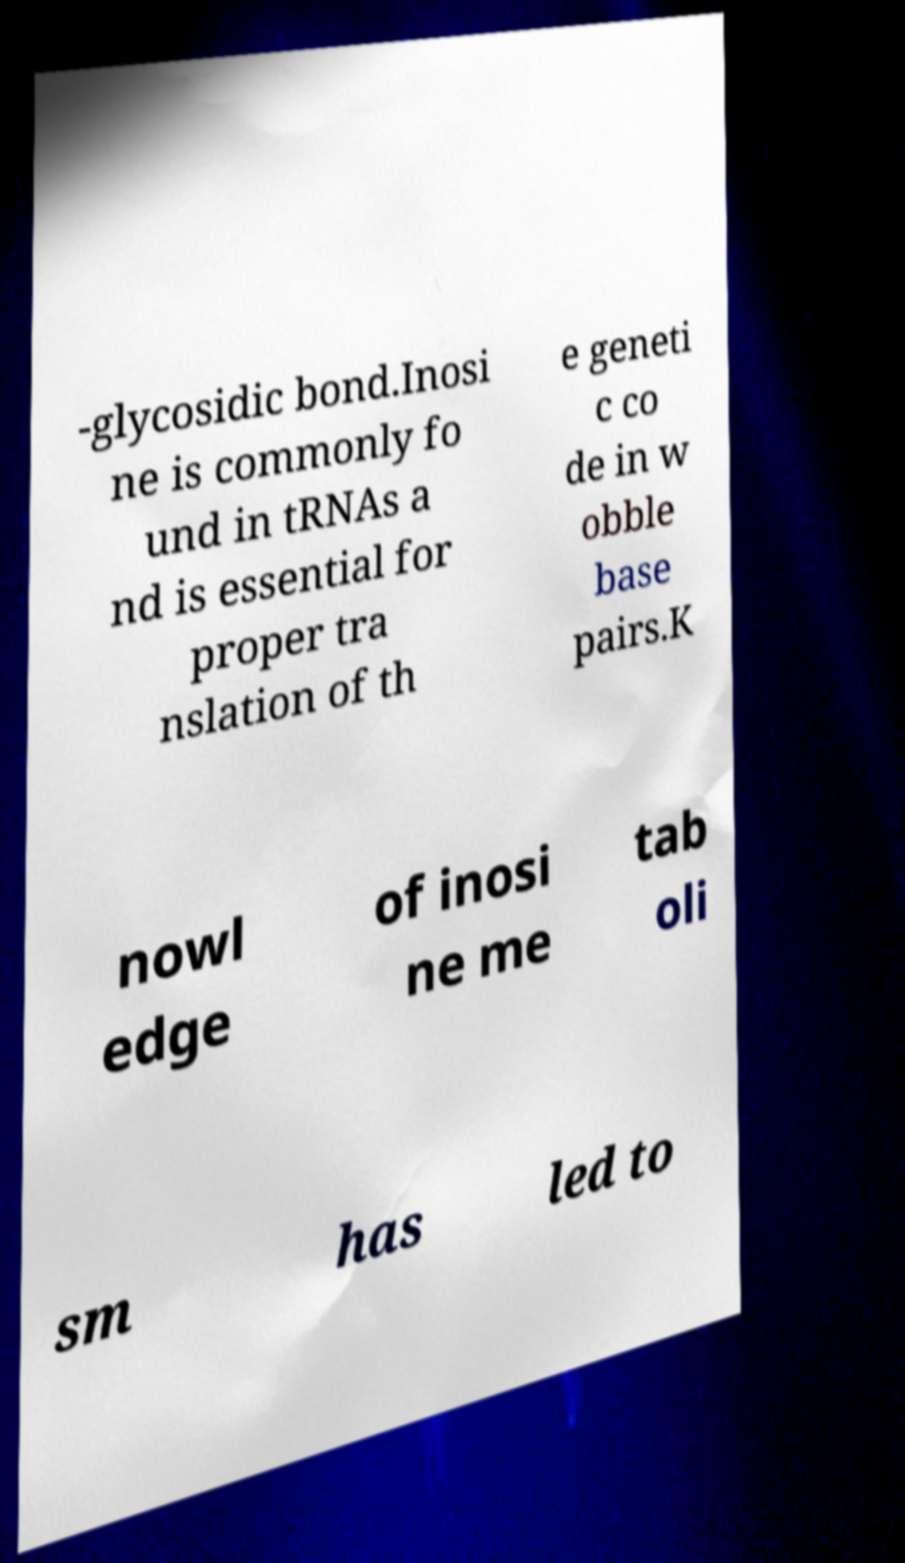What messages or text are displayed in this image? I need them in a readable, typed format. -glycosidic bond.Inosi ne is commonly fo und in tRNAs a nd is essential for proper tra nslation of th e geneti c co de in w obble base pairs.K nowl edge of inosi ne me tab oli sm has led to 